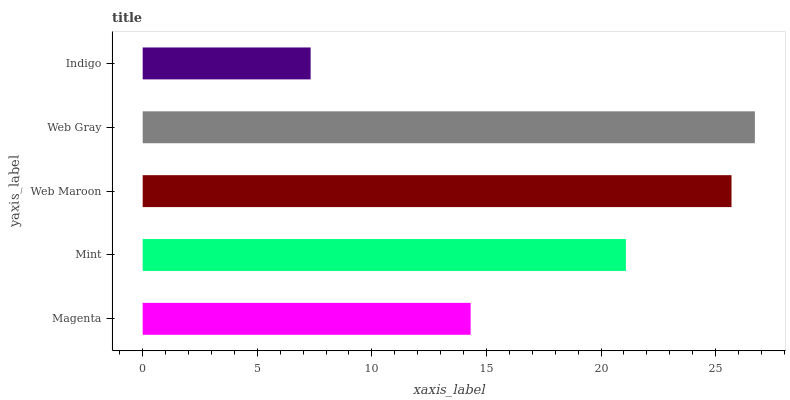Is Indigo the minimum?
Answer yes or no. Yes. Is Web Gray the maximum?
Answer yes or no. Yes. Is Mint the minimum?
Answer yes or no. No. Is Mint the maximum?
Answer yes or no. No. Is Mint greater than Magenta?
Answer yes or no. Yes. Is Magenta less than Mint?
Answer yes or no. Yes. Is Magenta greater than Mint?
Answer yes or no. No. Is Mint less than Magenta?
Answer yes or no. No. Is Mint the high median?
Answer yes or no. Yes. Is Mint the low median?
Answer yes or no. Yes. Is Magenta the high median?
Answer yes or no. No. Is Web Gray the low median?
Answer yes or no. No. 